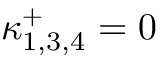Convert formula to latex. <formula><loc_0><loc_0><loc_500><loc_500>\kappa _ { 1 , 3 , 4 } ^ { + } = 0</formula> 